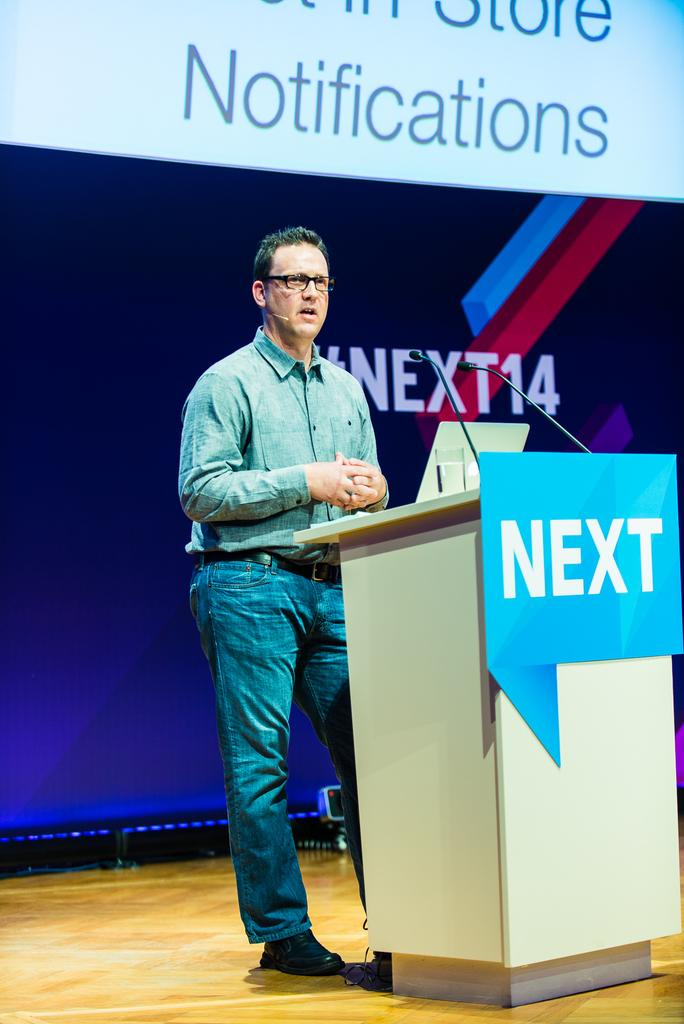Who or what is present in the image? There is a person in the image. What is the person wearing? The person is wearing clothes. What is the person doing in the image? The person is standing in front of a podium. What can be seen in the background of the image? There is text visible in the background of the image. What type of vegetable is growing in the garden in the image? There is no garden or vegetable present in the image. How does the ice help to cool the person down in the image? There is no ice present in the image, and the person's temperature is not mentioned. 